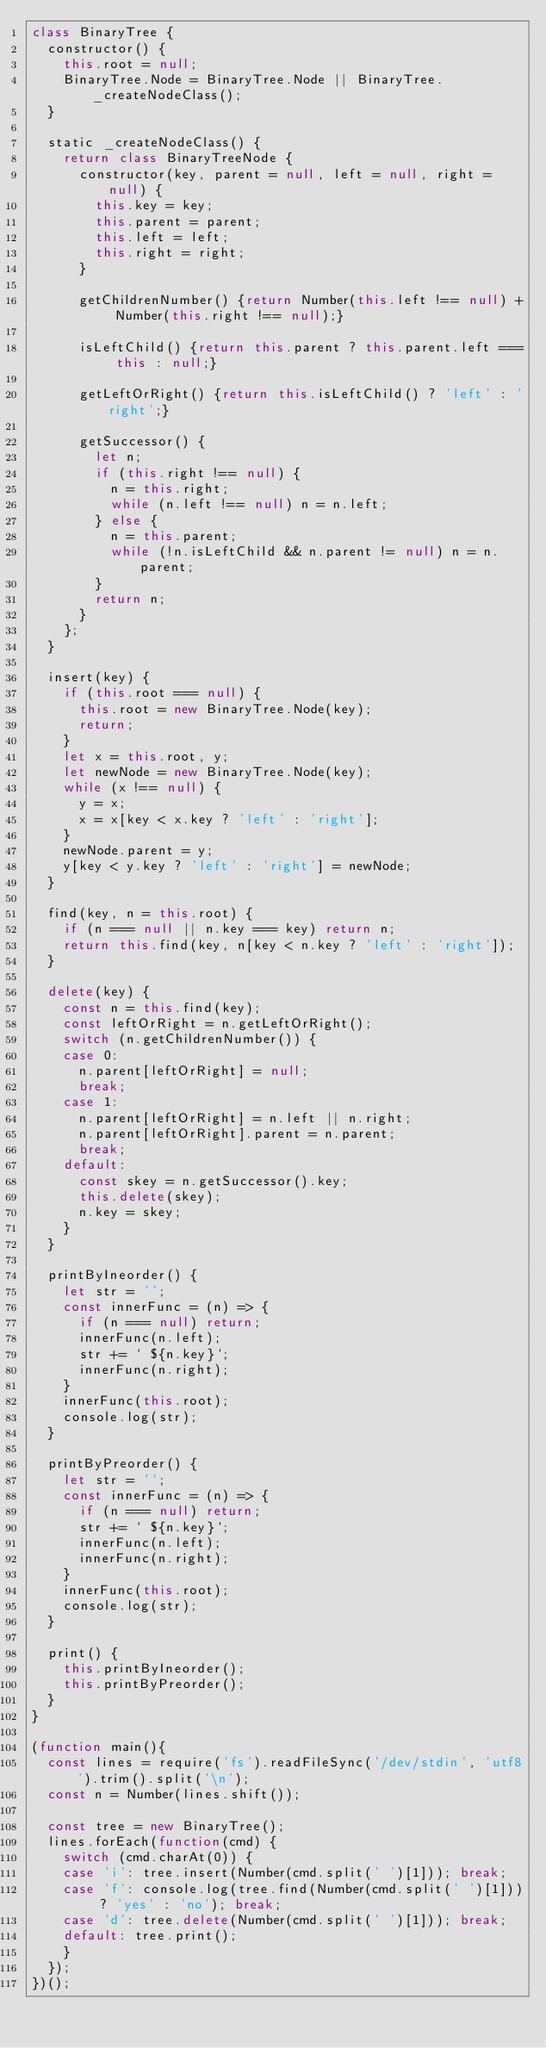<code> <loc_0><loc_0><loc_500><loc_500><_JavaScript_>class BinaryTree {
  constructor() {
    this.root = null;
    BinaryTree.Node = BinaryTree.Node || BinaryTree._createNodeClass();
  }

  static _createNodeClass() {
    return class BinaryTreeNode {
      constructor(key, parent = null, left = null, right = null) {
        this.key = key;
        this.parent = parent;
        this.left = left;
        this.right = right;
      }

      getChildrenNumber() {return Number(this.left !== null) + Number(this.right !== null);}

      isLeftChild() {return this.parent ? this.parent.left === this : null;}

      getLeftOrRight() {return this.isLeftChild() ? 'left' : 'right';}

      getSuccessor() {
        let n;
        if (this.right !== null) {
          n = this.right;
          while (n.left !== null) n = n.left;
        } else {
          n = this.parent;
          while (!n.isLeftChild && n.parent != null) n = n.parent;
        }
        return n;
      }
    };
  }

  insert(key) {
    if (this.root === null) {
      this.root = new BinaryTree.Node(key);
      return;
    }
    let x = this.root, y;
    let newNode = new BinaryTree.Node(key);
    while (x !== null) {
      y = x;
      x = x[key < x.key ? 'left' : 'right'];
    }
    newNode.parent = y;
    y[key < y.key ? 'left' : 'right'] = newNode;
  }

  find(key, n = this.root) {
    if (n === null || n.key === key) return n;
    return this.find(key, n[key < n.key ? 'left' : 'right']);
  }

  delete(key) {
    const n = this.find(key);
    const leftOrRight = n.getLeftOrRight();
    switch (n.getChildrenNumber()) {
    case 0:
      n.parent[leftOrRight] = null;
      break;
    case 1:
      n.parent[leftOrRight] = n.left || n.right;
      n.parent[leftOrRight].parent = n.parent;
      break;
    default:
      const skey = n.getSuccessor().key;
      this.delete(skey);
      n.key = skey;
    }
  }

  printByIneorder() {
    let str = '';
    const innerFunc = (n) => {
      if (n === null) return;
      innerFunc(n.left);
      str += ` ${n.key}`;
      innerFunc(n.right);
    }
    innerFunc(this.root);
    console.log(str);
  }

  printByPreorder() {
    let str = '';
    const innerFunc = (n) => {
      if (n === null) return;
      str += ` ${n.key}`;
      innerFunc(n.left);
      innerFunc(n.right);
    }
    innerFunc(this.root);
    console.log(str);
  }

  print() {
    this.printByIneorder();
    this.printByPreorder();
  }
}

(function main(){
  const lines = require('fs').readFileSync('/dev/stdin', 'utf8').trim().split('\n');
  const n = Number(lines.shift());

  const tree = new BinaryTree();
  lines.forEach(function(cmd) {
    switch (cmd.charAt(0)) {
    case 'i': tree.insert(Number(cmd.split(' ')[1])); break;
    case 'f': console.log(tree.find(Number(cmd.split(' ')[1])) ? 'yes' : 'no'); break;
    case 'd': tree.delete(Number(cmd.split(' ')[1])); break;
    default: tree.print();
    }
  });
})();

</code> 